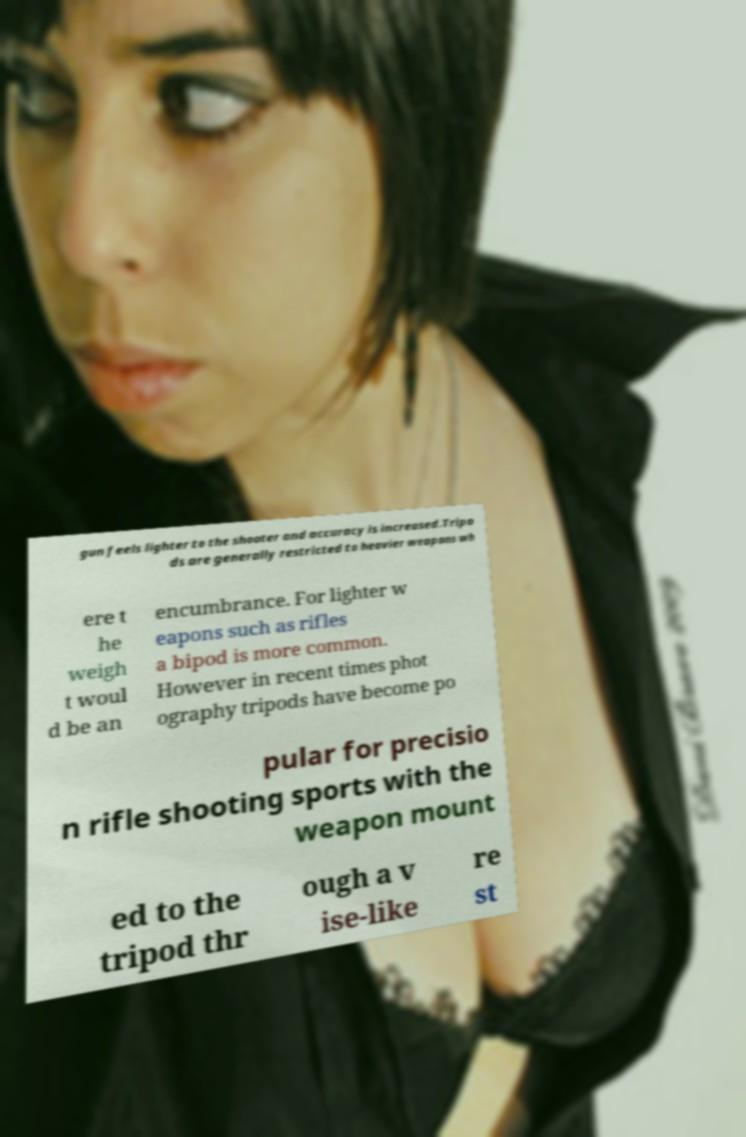What messages or text are displayed in this image? I need them in a readable, typed format. gun feels lighter to the shooter and accuracy is increased.Tripo ds are generally restricted to heavier weapons wh ere t he weigh t woul d be an encumbrance. For lighter w eapons such as rifles a bipod is more common. However in recent times phot ography tripods have become po pular for precisio n rifle shooting sports with the weapon mount ed to the tripod thr ough a v ise-like re st 